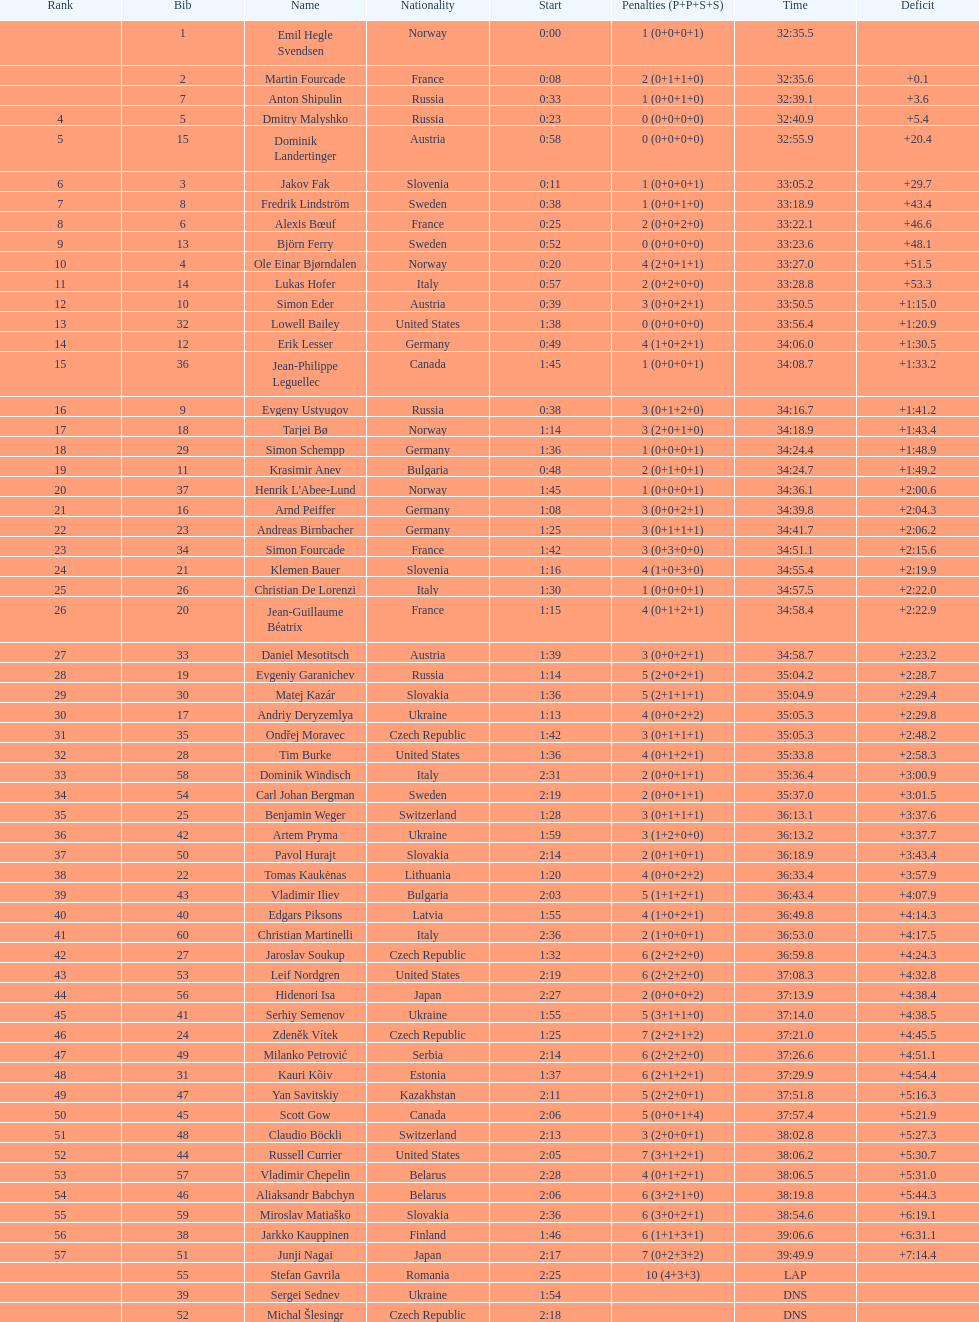In what amount of time did erik lesser complete? 34:06.0. 